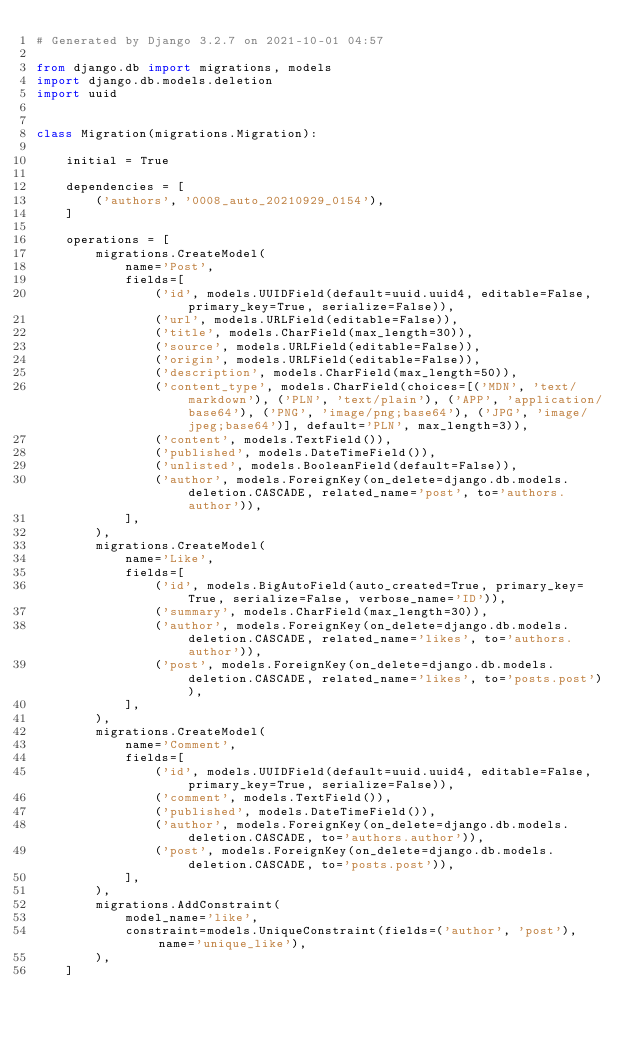<code> <loc_0><loc_0><loc_500><loc_500><_Python_># Generated by Django 3.2.7 on 2021-10-01 04:57

from django.db import migrations, models
import django.db.models.deletion
import uuid


class Migration(migrations.Migration):

    initial = True

    dependencies = [
        ('authors', '0008_auto_20210929_0154'),
    ]

    operations = [
        migrations.CreateModel(
            name='Post',
            fields=[
                ('id', models.UUIDField(default=uuid.uuid4, editable=False, primary_key=True, serialize=False)),
                ('url', models.URLField(editable=False)),
                ('title', models.CharField(max_length=30)),
                ('source', models.URLField(editable=False)),
                ('origin', models.URLField(editable=False)),
                ('description', models.CharField(max_length=50)),
                ('content_type', models.CharField(choices=[('MDN', 'text/markdown'), ('PLN', 'text/plain'), ('APP', 'application/base64'), ('PNG', 'image/png;base64'), ('JPG', 'image/jpeg;base64')], default='PLN', max_length=3)),
                ('content', models.TextField()),
                ('published', models.DateTimeField()),
                ('unlisted', models.BooleanField(default=False)),
                ('author', models.ForeignKey(on_delete=django.db.models.deletion.CASCADE, related_name='post', to='authors.author')),
            ],
        ),
        migrations.CreateModel(
            name='Like',
            fields=[
                ('id', models.BigAutoField(auto_created=True, primary_key=True, serialize=False, verbose_name='ID')),
                ('summary', models.CharField(max_length=30)),
                ('author', models.ForeignKey(on_delete=django.db.models.deletion.CASCADE, related_name='likes', to='authors.author')),
                ('post', models.ForeignKey(on_delete=django.db.models.deletion.CASCADE, related_name='likes', to='posts.post')),
            ],
        ),
        migrations.CreateModel(
            name='Comment',
            fields=[
                ('id', models.UUIDField(default=uuid.uuid4, editable=False, primary_key=True, serialize=False)),
                ('comment', models.TextField()),
                ('published', models.DateTimeField()),
                ('author', models.ForeignKey(on_delete=django.db.models.deletion.CASCADE, to='authors.author')),
                ('post', models.ForeignKey(on_delete=django.db.models.deletion.CASCADE, to='posts.post')),
            ],
        ),
        migrations.AddConstraint(
            model_name='like',
            constraint=models.UniqueConstraint(fields=('author', 'post'), name='unique_like'),
        ),
    ]
</code> 